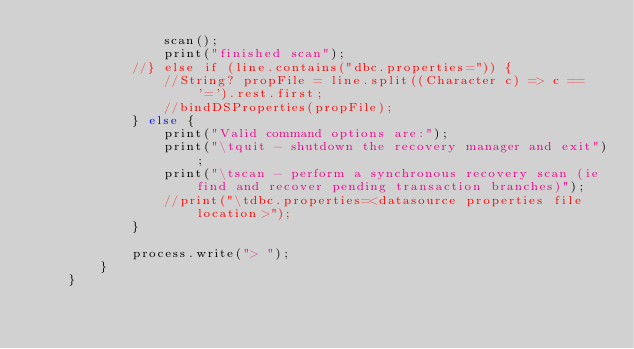Convert code to text. <code><loc_0><loc_0><loc_500><loc_500><_Ceylon_>                scan();
                print("finished scan");
            //} else if (line.contains("dbc.properties=")) {
                //String? propFile = line.split((Character c) => c == '=').rest.first;
                //bindDSProperties(propFile);
            } else {
                print("Valid command options are:");
                print("\tquit - shutdown the recovery manager and exit");
                print("\tscan - perform a synchronous recovery scan (ie find and recover pending transaction branches)");
                //print("\tdbc.properties=<datasource properties file location>");
            }

            process.write("> ");
        }
    }
</code> 